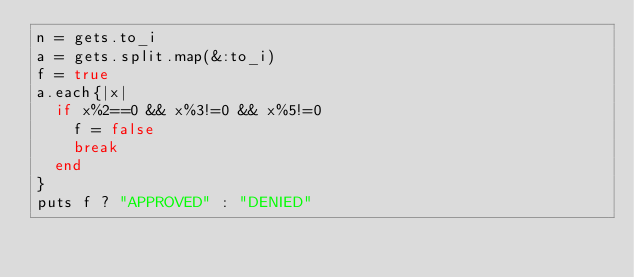Convert code to text. <code><loc_0><loc_0><loc_500><loc_500><_Ruby_>n = gets.to_i
a = gets.split.map(&:to_i)
f = true
a.each{|x|
  if x%2==0 && x%3!=0 && x%5!=0
    f = false
    break
  end
}
puts f ? "APPROVED" : "DENIED"
</code> 